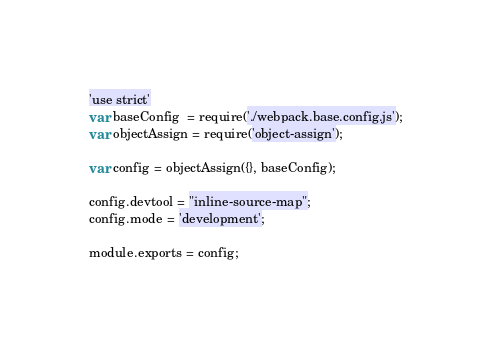<code> <loc_0><loc_0><loc_500><loc_500><_JavaScript_>'use strict'
var baseConfig  = require('./webpack.base.config.js');
var objectAssign = require('object-assign');

var config = objectAssign({}, baseConfig);

config.devtool = "inline-source-map";
config.mode = 'development';

module.exports = config;</code> 